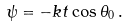<formula> <loc_0><loc_0><loc_500><loc_500>\psi = - k t \cos \theta _ { 0 } \, .</formula> 